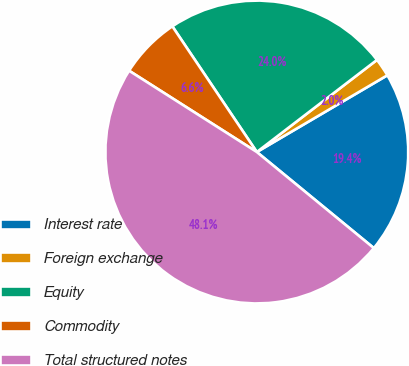<chart> <loc_0><loc_0><loc_500><loc_500><pie_chart><fcel>Interest rate<fcel>Foreign exchange<fcel>Equity<fcel>Commodity<fcel>Total structured notes<nl><fcel>19.4%<fcel>1.95%<fcel>24.01%<fcel>6.56%<fcel>48.08%<nl></chart> 